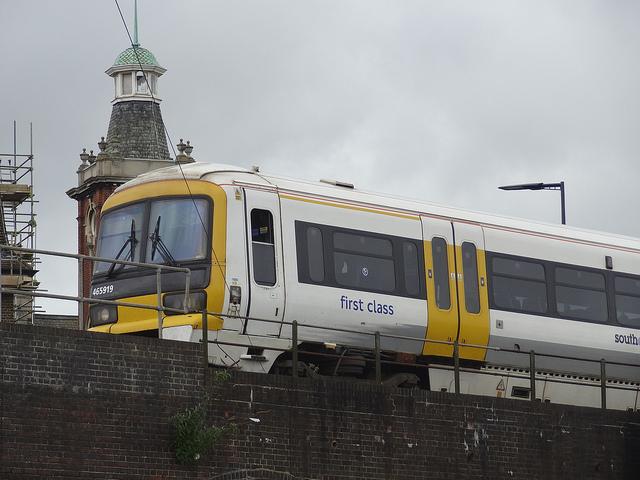What color stands out?
Answer briefly. Yellow. How many people are not in the bus?
Quick response, please. 0. How many windows are on the bus?
Be succinct. 15. Is this a modern train?
Write a very short answer. Yes. Is it a cloudy day?
Write a very short answer. Yes. Can this bus transport freight?
Give a very brief answer. No. 